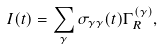<formula> <loc_0><loc_0><loc_500><loc_500>I ( t ) = \sum _ { \gamma } \sigma _ { \gamma \gamma } ( t ) \Gamma ^ { ( \gamma ) } _ { R } ,</formula> 